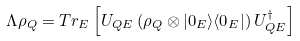<formula> <loc_0><loc_0><loc_500><loc_500>\Lambda \rho _ { Q } = T r _ { E } \left [ U _ { Q E } \left ( \rho _ { Q } \otimes | 0 _ { E } \rangle \langle 0 _ { E } | \right ) U _ { Q E } ^ { \dag } \right ]</formula> 